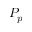Convert formula to latex. <formula><loc_0><loc_0><loc_500><loc_500>P _ { p }</formula> 